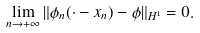<formula> <loc_0><loc_0><loc_500><loc_500>\lim _ { n \rightarrow + \infty } \| \phi _ { n } ( \cdot - x _ { n } ) - \phi \| _ { H ^ { 1 } } = 0 .</formula> 